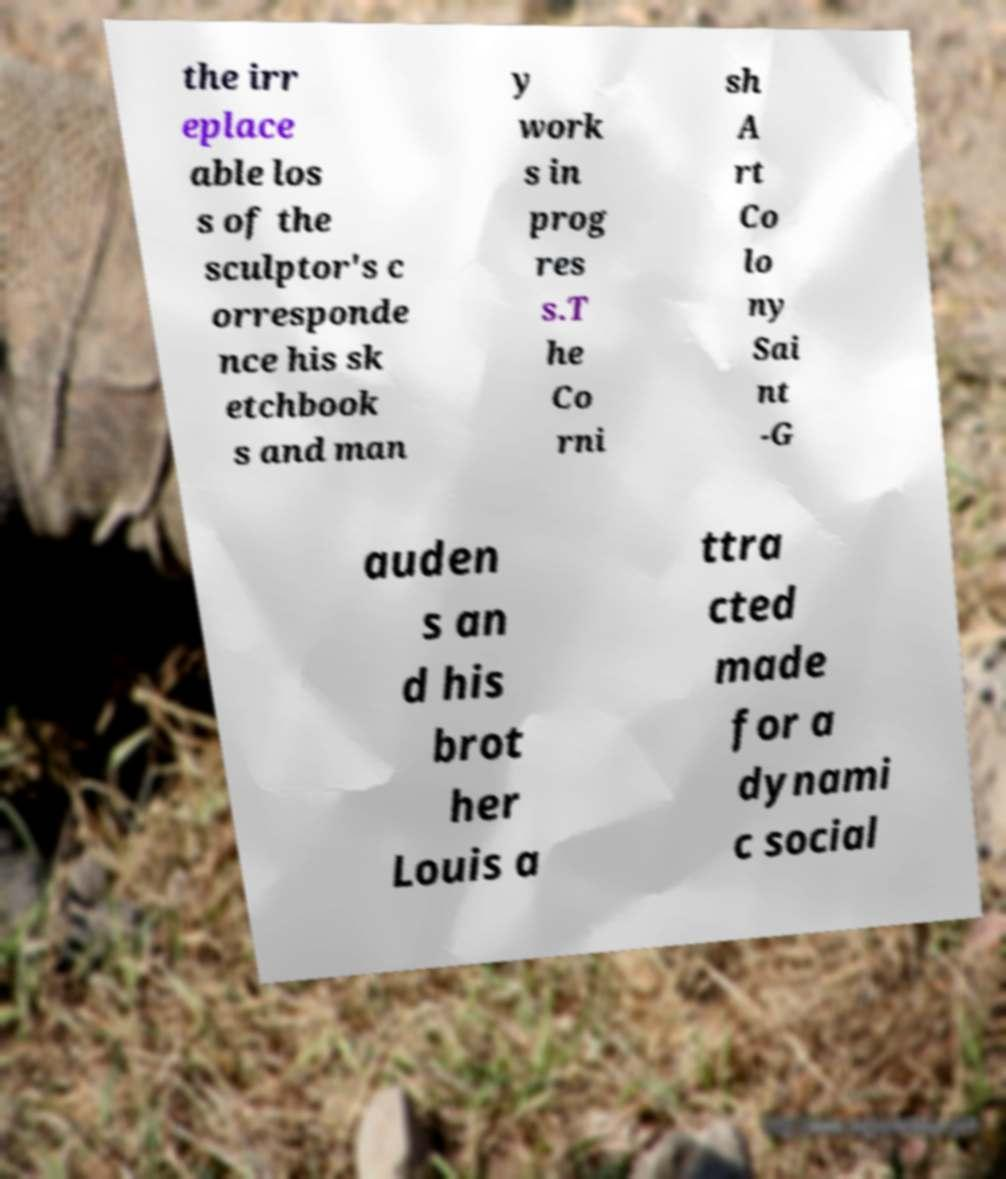Can you accurately transcribe the text from the provided image for me? the irr eplace able los s of the sculptor's c orresponde nce his sk etchbook s and man y work s in prog res s.T he Co rni sh A rt Co lo ny Sai nt -G auden s an d his brot her Louis a ttra cted made for a dynami c social 